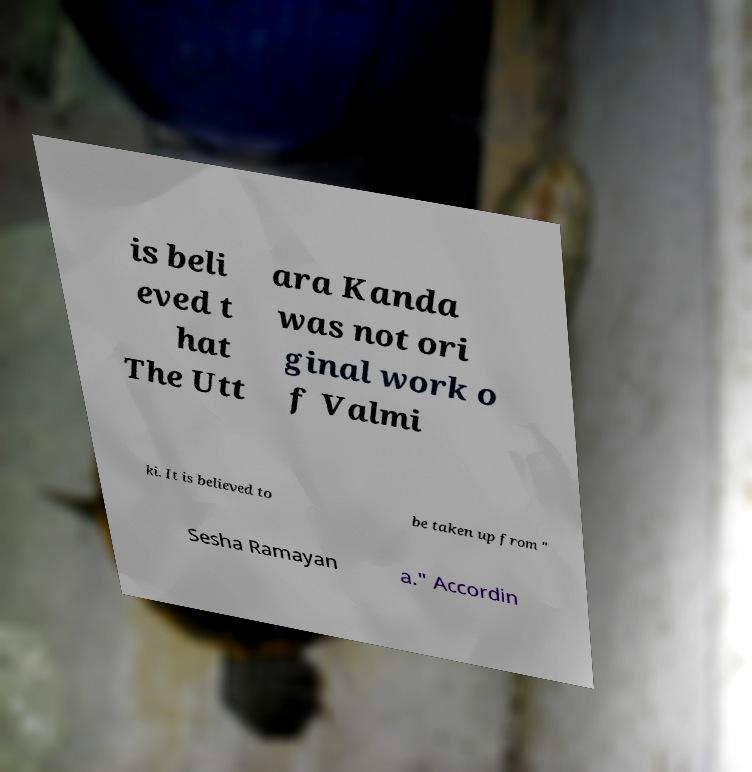For documentation purposes, I need the text within this image transcribed. Could you provide that? is beli eved t hat The Utt ara Kanda was not ori ginal work o f Valmi ki. It is believed to be taken up from " Sesha Ramayan a." Accordin 